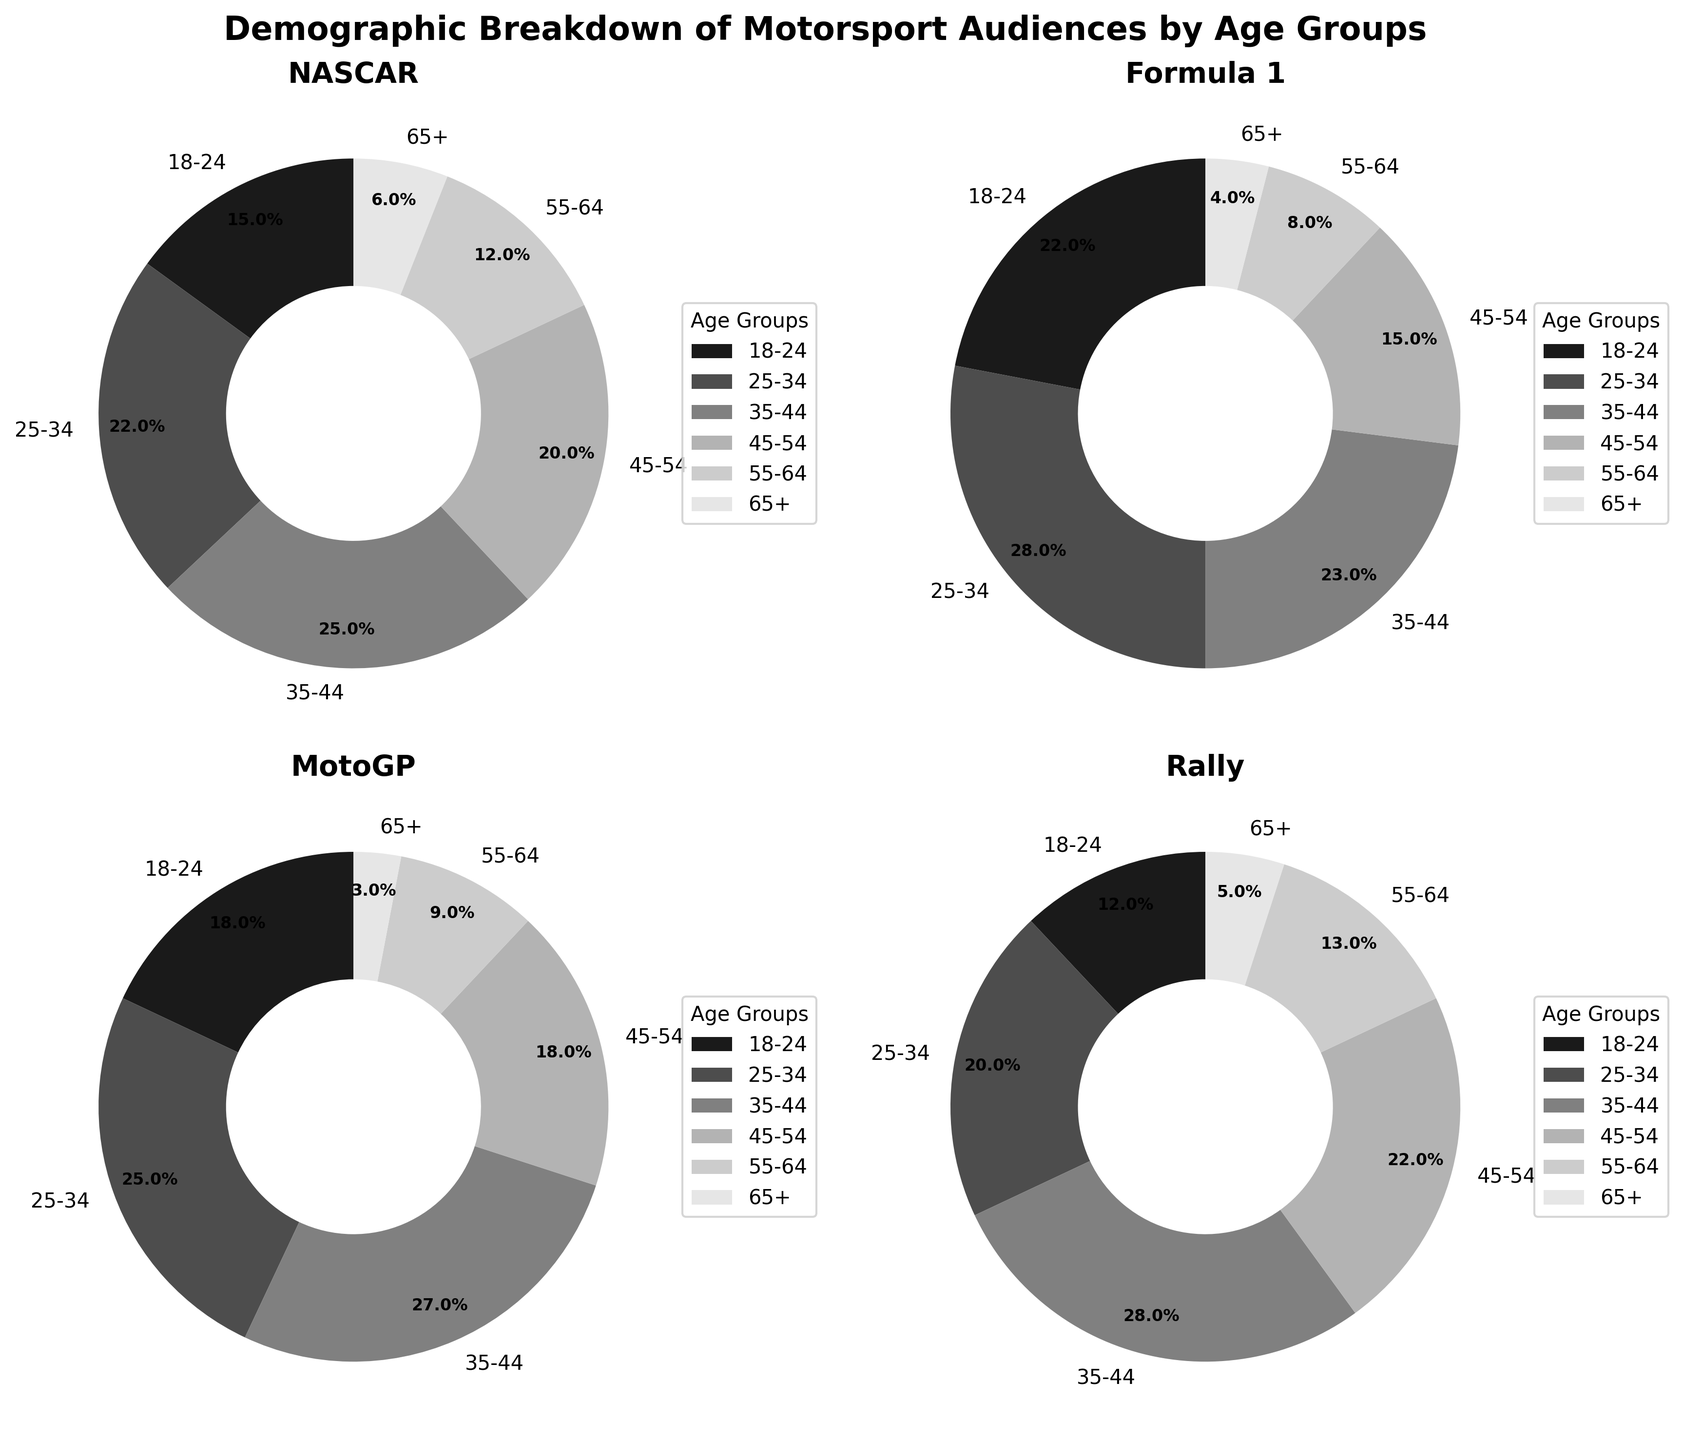What is the title of the figure? The title is displayed at the top center of the figure and reads 'Demographic Breakdown of Motorsport Audiences by Age Groups'.
Answer: Demographic Breakdown of Motorsport Audiences by Age Groups Which sport has the highest percentage of 25-34 age group audiences? In the pie charts, the 25-34 age group has different percentages for different sports. By comparing visually, the highest percentage for the 25-34 age group is found in the 'Formula 1' pie chart.
Answer: Formula 1 What is the combined percentage of the 18-24 and 25-34 age groups for NASCAR fans? For NASCAR, the 18-24 and 25-34 age groups are 15% and 22%, respectively. Adding these percentages gives 15% + 22% = 37%.
Answer: 37% Which sport has the smallest percentage of audiences in the 65+ age group? By examining the segments labeled '65+' in each pie chart, the smallest segment visually identifies 'MotoGP' with 3%.
Answer: MotoGP How does the percentage of 35-44 age group for MotoGP compare to that of NASCAR? In the pie charts, the 35-44 age group for MotoGP is 27% and for NASCAR is 25%. Comparing the two, 27% is greater than 25%.
Answer: MotoGP has a higher percentage What is the most represented age group in the Rally audience? By looking at the Rally pie chart, the largest segment is the 35-44 age group, which makes up the highest percentage.
Answer: 35-44 Among all the age groups, which one has the highest representation in any category, and in which sport does it occur? Analyzing all pie charts, the 35-44 age group in 'Rally' has the highest single representation at 28%.
Answer: 35-44 in Rally What is the average percentage representation of the 45-54 age group across all sports? Sum the percentages of the 45-54 age group across all sports and divide by 4: (20% + 15% + 18% + 22%) / 4 = 18.75%.
Answer: 18.75% Compare the percentage representation of the 55-64 age group in Formula 1 and MotoGP? From the pie charts, Formula 1 has 8% and MotoGP has 9% for the 55-64 age group. Formula 1’s percentage is smaller than MotoGP’s.
Answer: Formula 1 is smaller Which age group makes up the smallest segment of the NASCAR audience? Reviewing the NASCAR pie chart, the segment for the 65+ age group is the smallest and makes up 6%.
Answer: 65+ 